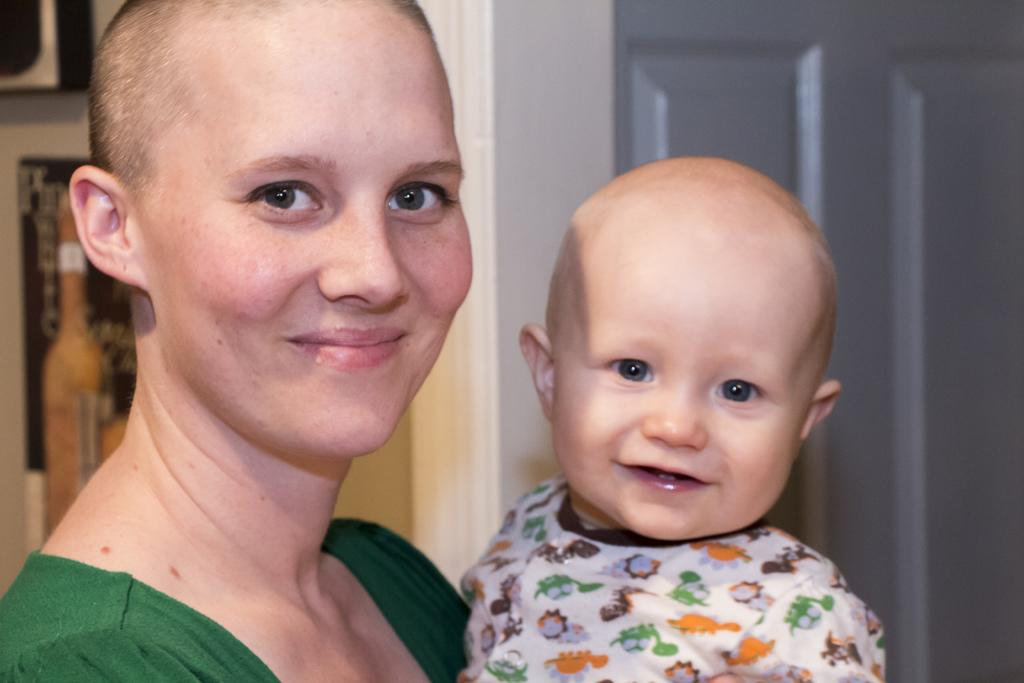Who is present in the image? There is a woman and a child in the image. Can you describe the setting of the image? The image features a woman and a child, with a door visible in the background. What type of toothbrush is the horse using in the image? There is no horse or toothbrush present in the image. 